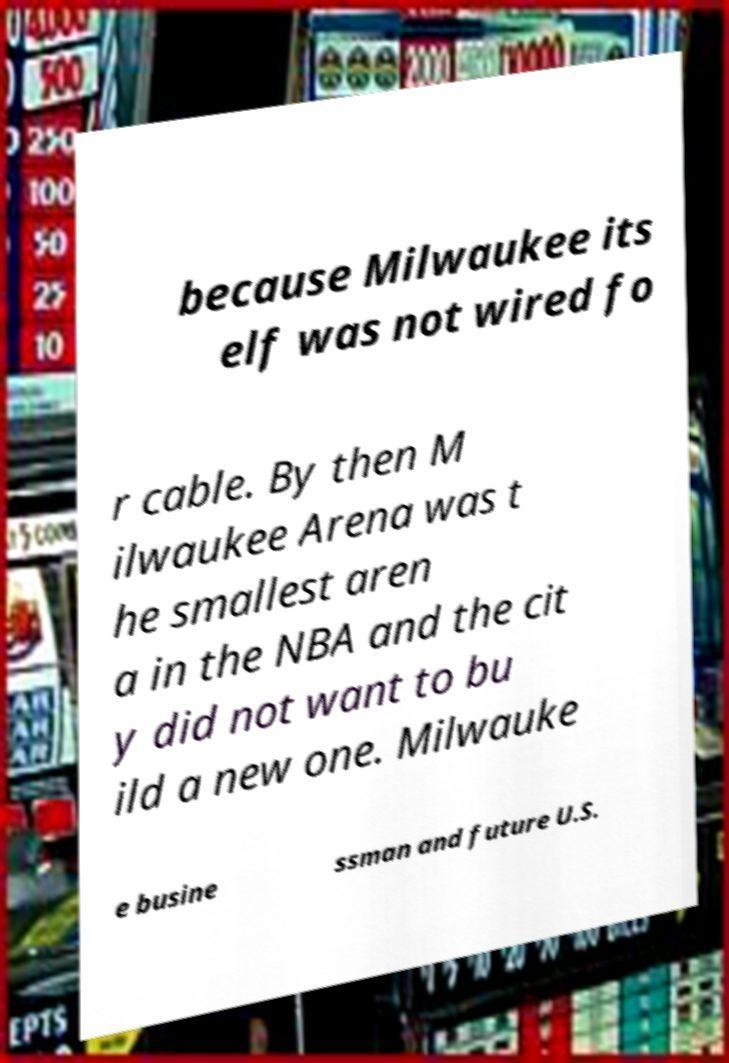There's text embedded in this image that I need extracted. Can you transcribe it verbatim? because Milwaukee its elf was not wired fo r cable. By then M ilwaukee Arena was t he smallest aren a in the NBA and the cit y did not want to bu ild a new one. Milwauke e busine ssman and future U.S. 